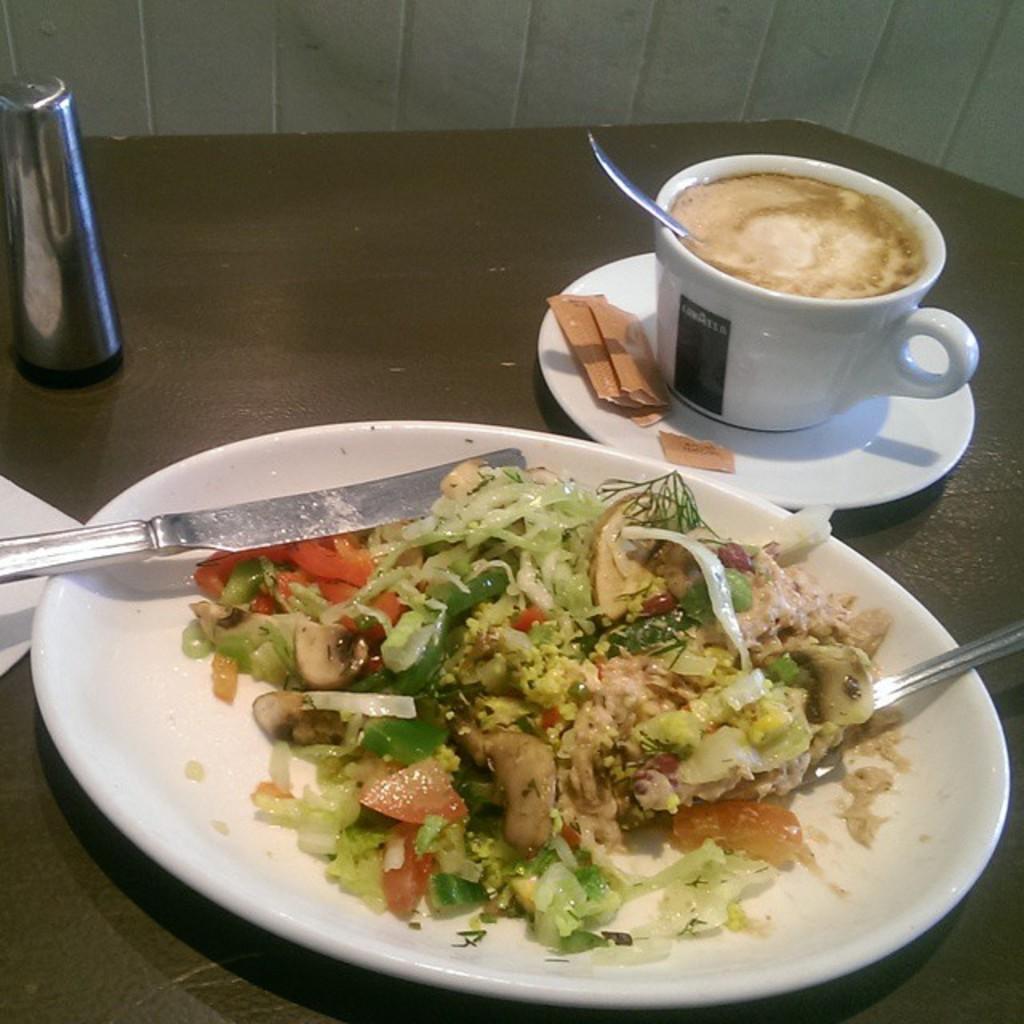Please provide a concise description of this image. In this image we can see a cup and a plate containing food and spoons in it placed on the table. In the background, we can see a container. 